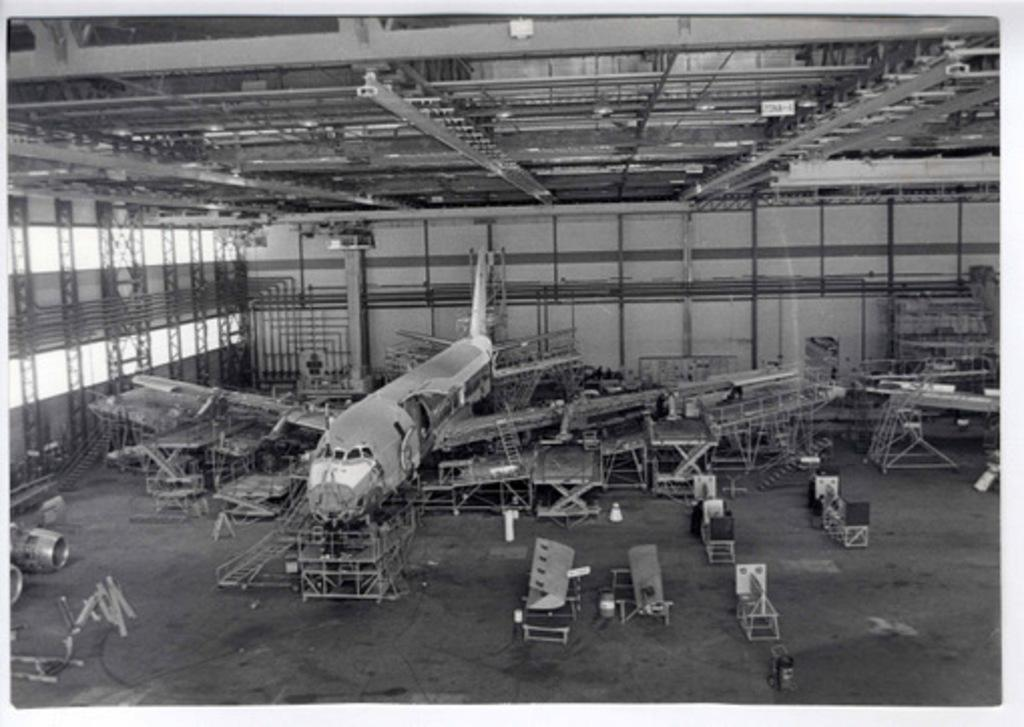What is the color scheme of the image? The image is black and white. What structure can be seen in the image? There is a shed in the image. What is inside the shed? There is an airplane inside the shed, along with other parts. What type of canvas is being used to paint the airplane in the image? There is no canvas or painting activity present in the image; it features a shed with an airplane inside. 